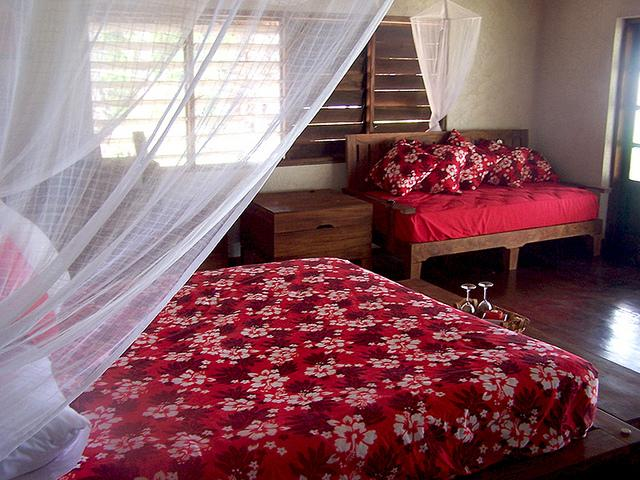What holiday is the color pattern on the bed most appropriate for? valentines day 